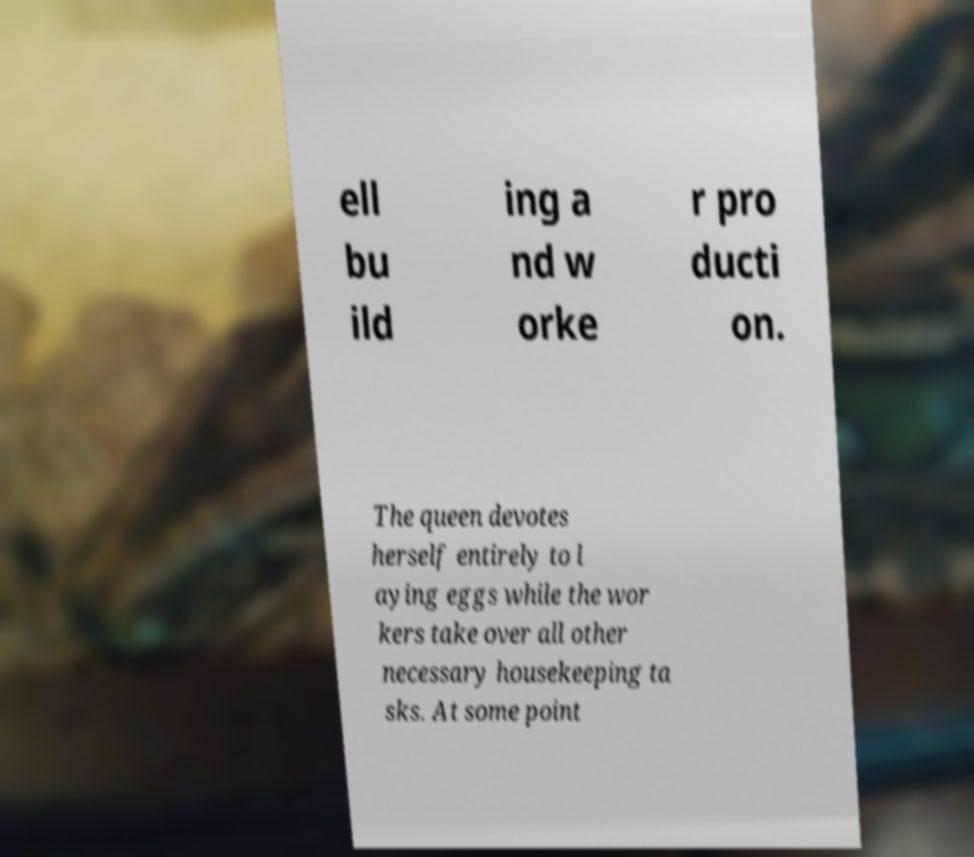Please identify and transcribe the text found in this image. ell bu ild ing a nd w orke r pro ducti on. The queen devotes herself entirely to l aying eggs while the wor kers take over all other necessary housekeeping ta sks. At some point 